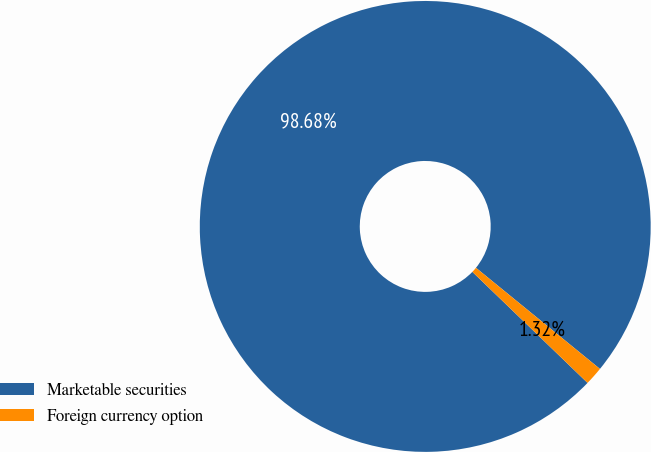Convert chart to OTSL. <chart><loc_0><loc_0><loc_500><loc_500><pie_chart><fcel>Marketable securities<fcel>Foreign currency option<nl><fcel>98.68%<fcel>1.32%<nl></chart> 